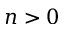<formula> <loc_0><loc_0><loc_500><loc_500>n > 0</formula> 